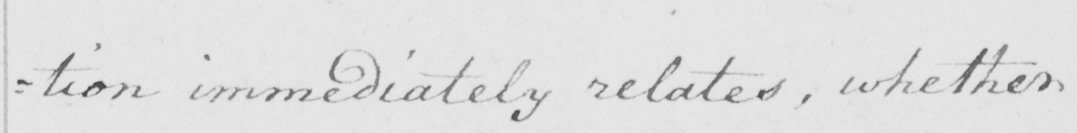Can you tell me what this handwritten text says? =tion immediately relates, whether 